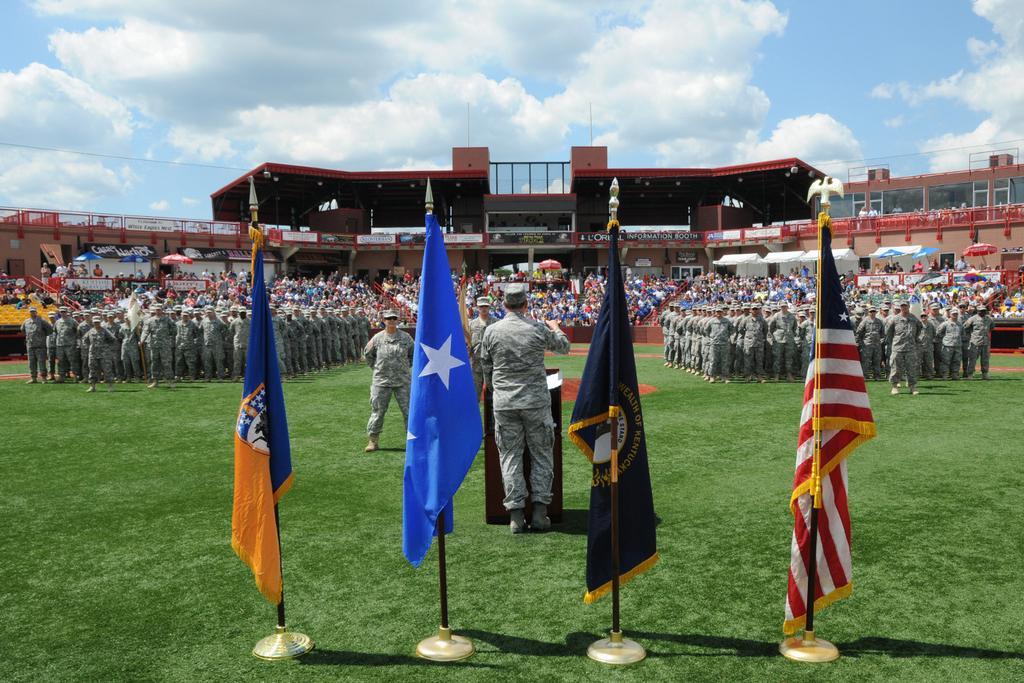Describe this image in one or two sentences. In this image there are flags at the poles, at the back there are so many people standing on the ground wearing uniform, at the back there is a stadium where people are sitting. 